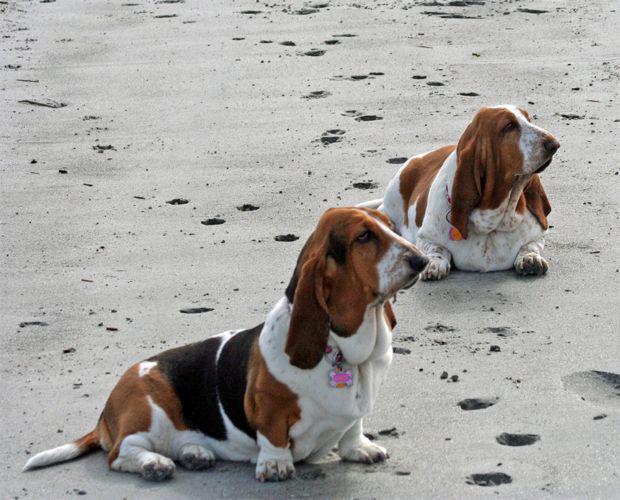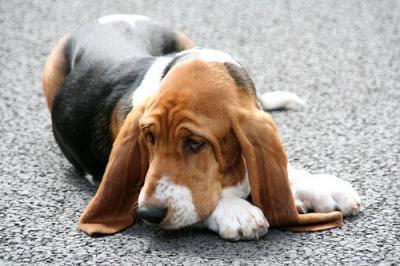The first image is the image on the left, the second image is the image on the right. Evaluate the accuracy of this statement regarding the images: "An image shows one basset hound, which is looking up and toward the right.". Is it true? Answer yes or no. No. 